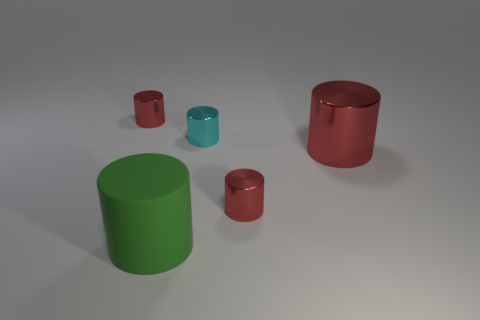Is there anything else that is the same material as the green cylinder?
Offer a very short reply. No. There is a cyan metallic thing that is on the left side of the big cylinder that is to the right of the green rubber cylinder; what shape is it?
Your answer should be compact. Cylinder. Is the number of cylinders greater than the number of small cyan cylinders?
Provide a short and direct response. Yes. How many things are both right of the green thing and in front of the large red cylinder?
Your answer should be very brief. 1. How many metallic cylinders are right of the cyan cylinder behind the large rubber thing?
Make the answer very short. 2. What number of things are red things to the right of the matte object or tiny red things that are to the left of the rubber object?
Ensure brevity in your answer.  3. What is the material of the cyan object that is the same shape as the large green object?
Provide a short and direct response. Metal. How many things are either tiny cylinders that are in front of the big red shiny thing or tiny cylinders?
Offer a terse response. 3. What is the shape of the cyan thing that is the same material as the large red thing?
Your response must be concise. Cylinder. How many green objects have the same shape as the tiny cyan metallic thing?
Ensure brevity in your answer.  1. 